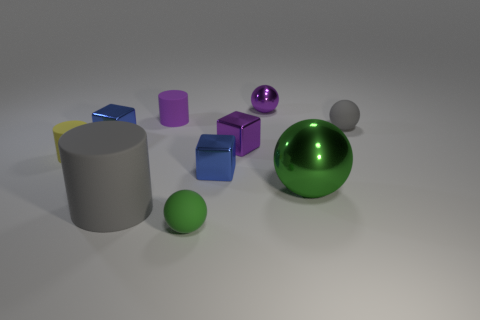There is a metal block that is the same color as the small metallic ball; what size is it?
Give a very brief answer. Small. What shape is the tiny gray object that is behind the gray matte thing that is in front of the small gray thing?
Your answer should be compact. Sphere. What number of other things are there of the same shape as the green rubber object?
Make the answer very short. 3. There is a blue metal block that is to the right of the shiny object to the left of the small green rubber object; what size is it?
Offer a very short reply. Small. Is there a gray cylinder?
Make the answer very short. Yes. There is a small blue shiny thing left of the tiny purple cylinder; what number of metal things are in front of it?
Your answer should be compact. 3. What shape is the large object that is left of the tiny green sphere?
Provide a short and direct response. Cylinder. There is a ball that is behind the small rubber object right of the small blue metallic object that is right of the tiny green object; what is its material?
Give a very brief answer. Metal. How many other objects are the same size as the yellow object?
Offer a terse response. 7. What is the material of the large thing that is the same shape as the small yellow matte object?
Give a very brief answer. Rubber. 